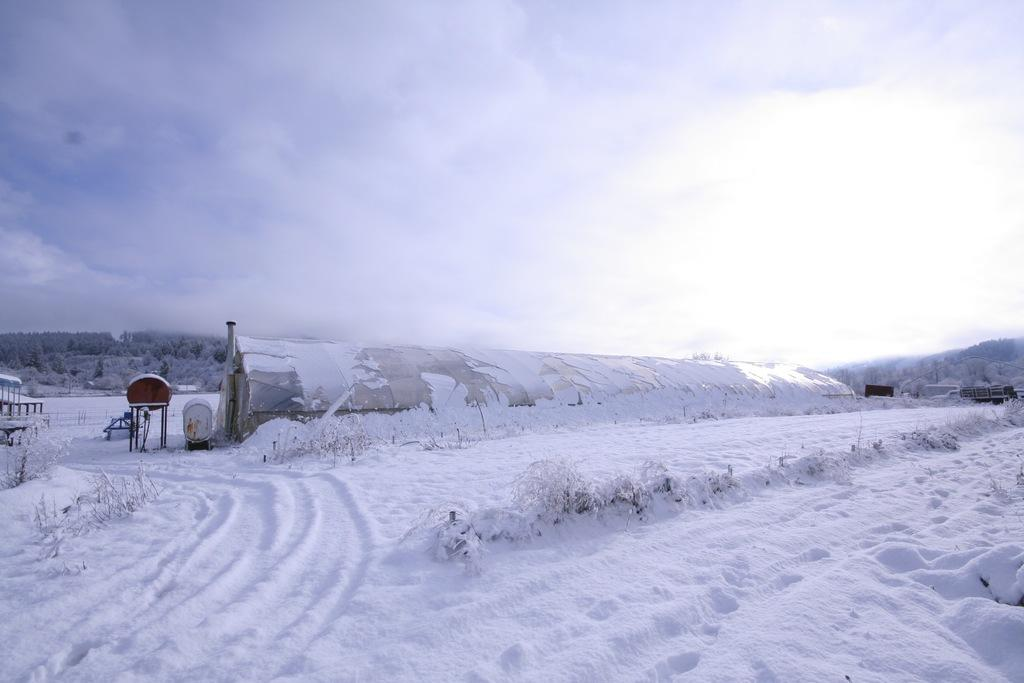What type of structure is present in the image? There is a shed in the image. What is covering the ground in the image? There are objects on the snow in the image. What can be seen in the distance in the image? Trees are visible in the background of the image. What else is visible in the background of the image? The sky is visible in the background of the image. How many feet are visible in the image? There are no feet visible in the image. What type of day is it in the image? The image does not provide information about the day or the weather. 